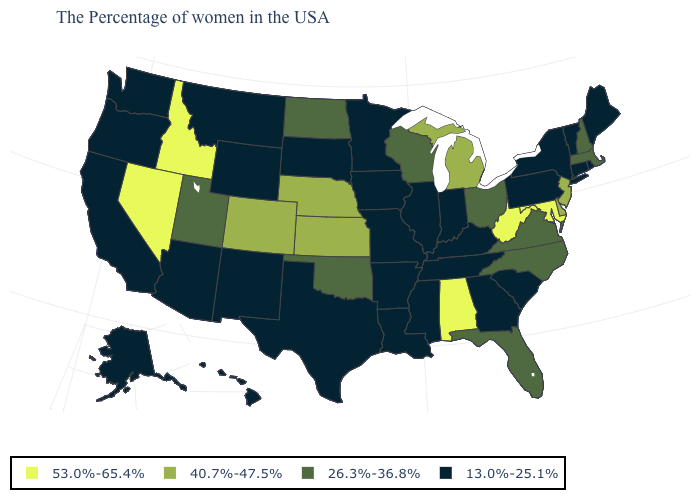What is the value of Illinois?
Write a very short answer. 13.0%-25.1%. Which states have the lowest value in the USA?
Concise answer only. Maine, Rhode Island, Vermont, Connecticut, New York, Pennsylvania, South Carolina, Georgia, Kentucky, Indiana, Tennessee, Illinois, Mississippi, Louisiana, Missouri, Arkansas, Minnesota, Iowa, Texas, South Dakota, Wyoming, New Mexico, Montana, Arizona, California, Washington, Oregon, Alaska, Hawaii. What is the value of Texas?
Answer briefly. 13.0%-25.1%. What is the lowest value in the USA?
Short answer required. 13.0%-25.1%. What is the value of Utah?
Answer briefly. 26.3%-36.8%. Does Oklahoma have the lowest value in the South?
Give a very brief answer. No. Does Kansas have the highest value in the MidWest?
Short answer required. Yes. Which states have the lowest value in the Northeast?
Short answer required. Maine, Rhode Island, Vermont, Connecticut, New York, Pennsylvania. What is the highest value in states that border Maryland?
Write a very short answer. 53.0%-65.4%. Does Virginia have the lowest value in the USA?
Concise answer only. No. Which states have the lowest value in the USA?
Answer briefly. Maine, Rhode Island, Vermont, Connecticut, New York, Pennsylvania, South Carolina, Georgia, Kentucky, Indiana, Tennessee, Illinois, Mississippi, Louisiana, Missouri, Arkansas, Minnesota, Iowa, Texas, South Dakota, Wyoming, New Mexico, Montana, Arizona, California, Washington, Oregon, Alaska, Hawaii. Does Michigan have a lower value than Delaware?
Quick response, please. No. Name the states that have a value in the range 26.3%-36.8%?
Write a very short answer. Massachusetts, New Hampshire, Virginia, North Carolina, Ohio, Florida, Wisconsin, Oklahoma, North Dakota, Utah. Does the map have missing data?
Short answer required. No. 